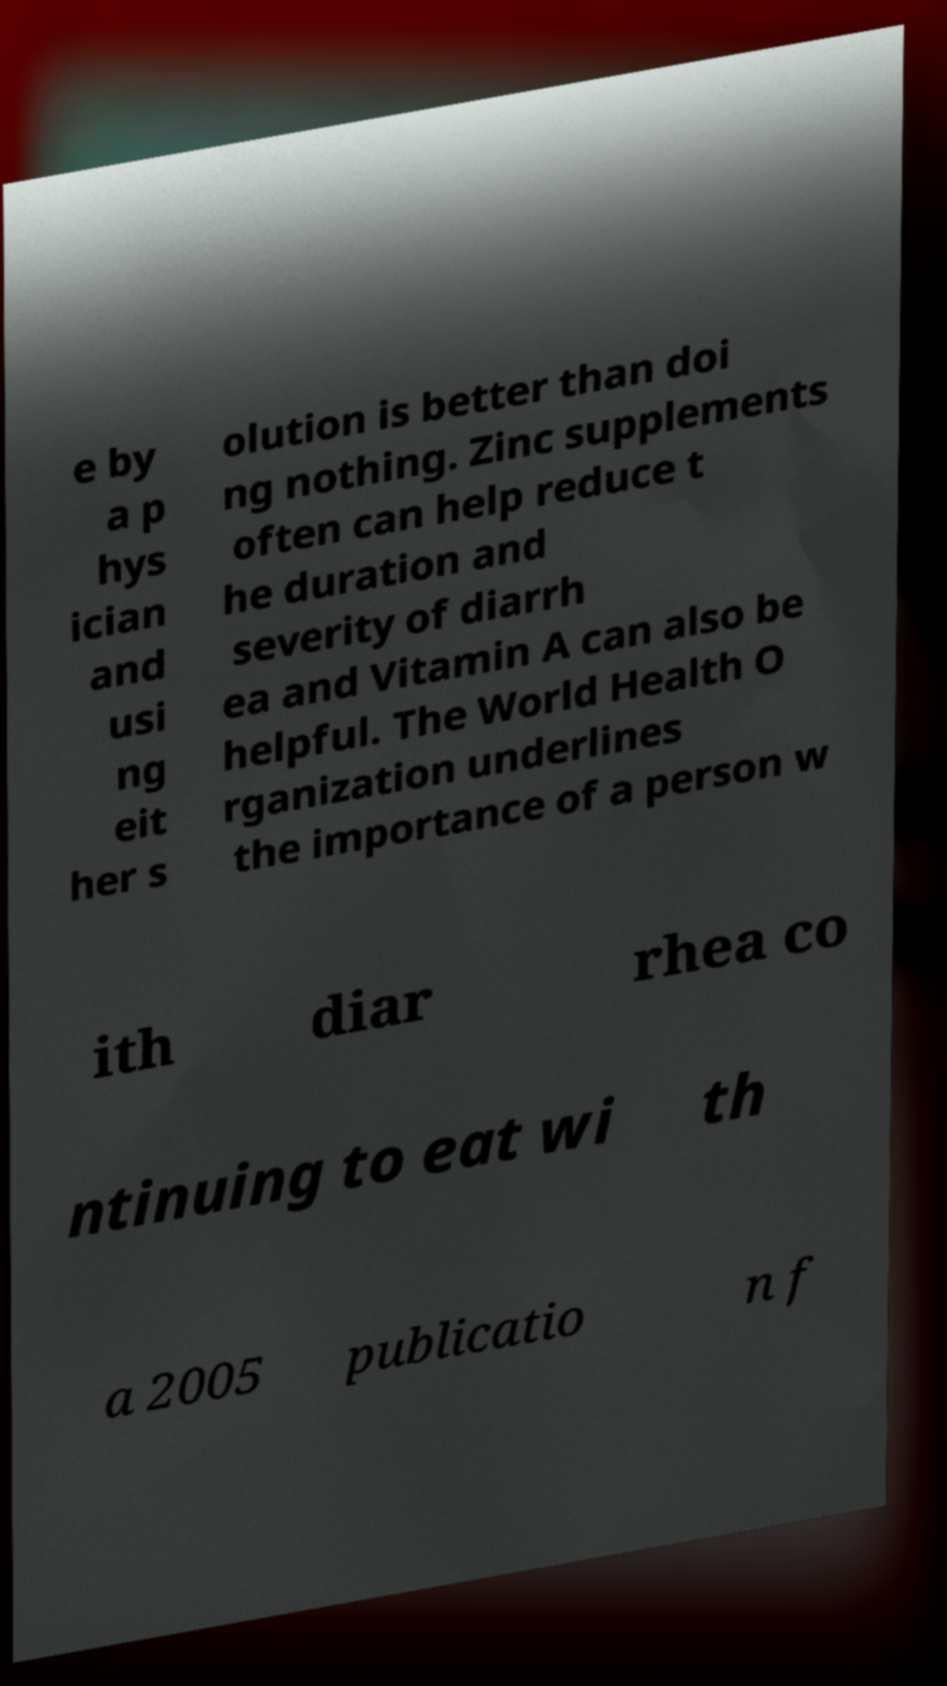Could you assist in decoding the text presented in this image and type it out clearly? e by a p hys ician and usi ng eit her s olution is better than doi ng nothing. Zinc supplements often can help reduce t he duration and severity of diarrh ea and Vitamin A can also be helpful. The World Health O rganization underlines the importance of a person w ith diar rhea co ntinuing to eat wi th a 2005 publicatio n f 